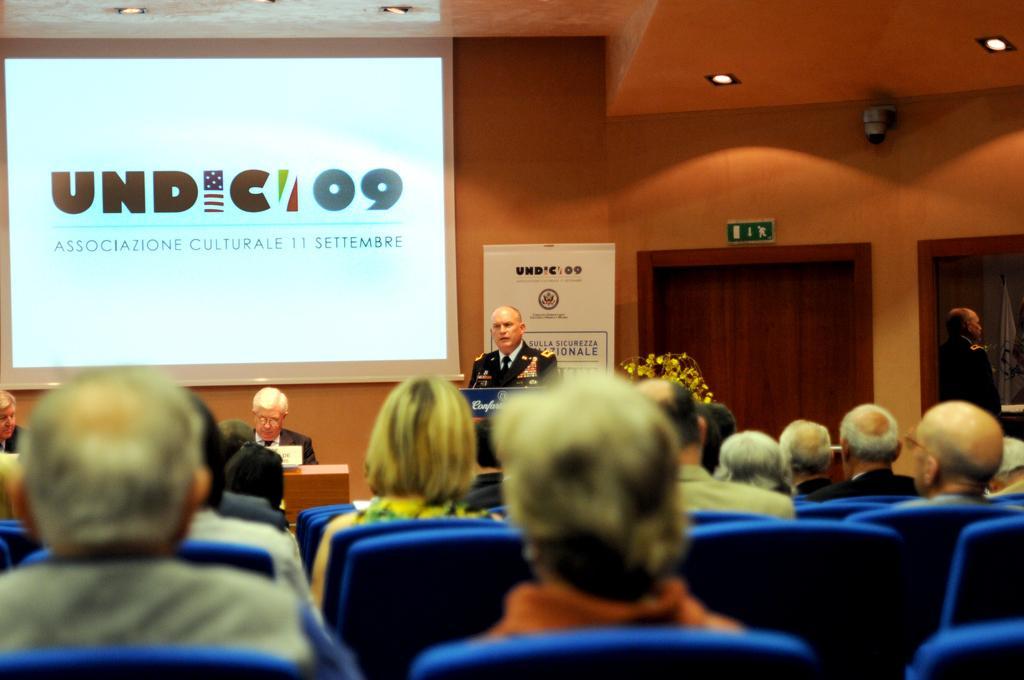Please provide a concise description of this image. In this picture we can see people are sitting on the chair and at the back side there is a projector. Bedside projector there is a person standing and in front of the projector there are two persons sitting on the chair. At the right side of the image there is a door and at the top of the roof there are two fall ceiling lights. 